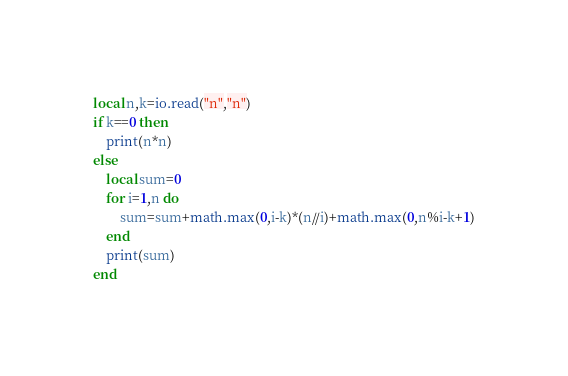<code> <loc_0><loc_0><loc_500><loc_500><_Lua_>local n,k=io.read("n","n")
if k==0 then
    print(n*n)
else
    local sum=0
    for i=1,n do
        sum=sum+math.max(0,i-k)*(n//i)+math.max(0,n%i-k+1)
    end
    print(sum)
end</code> 